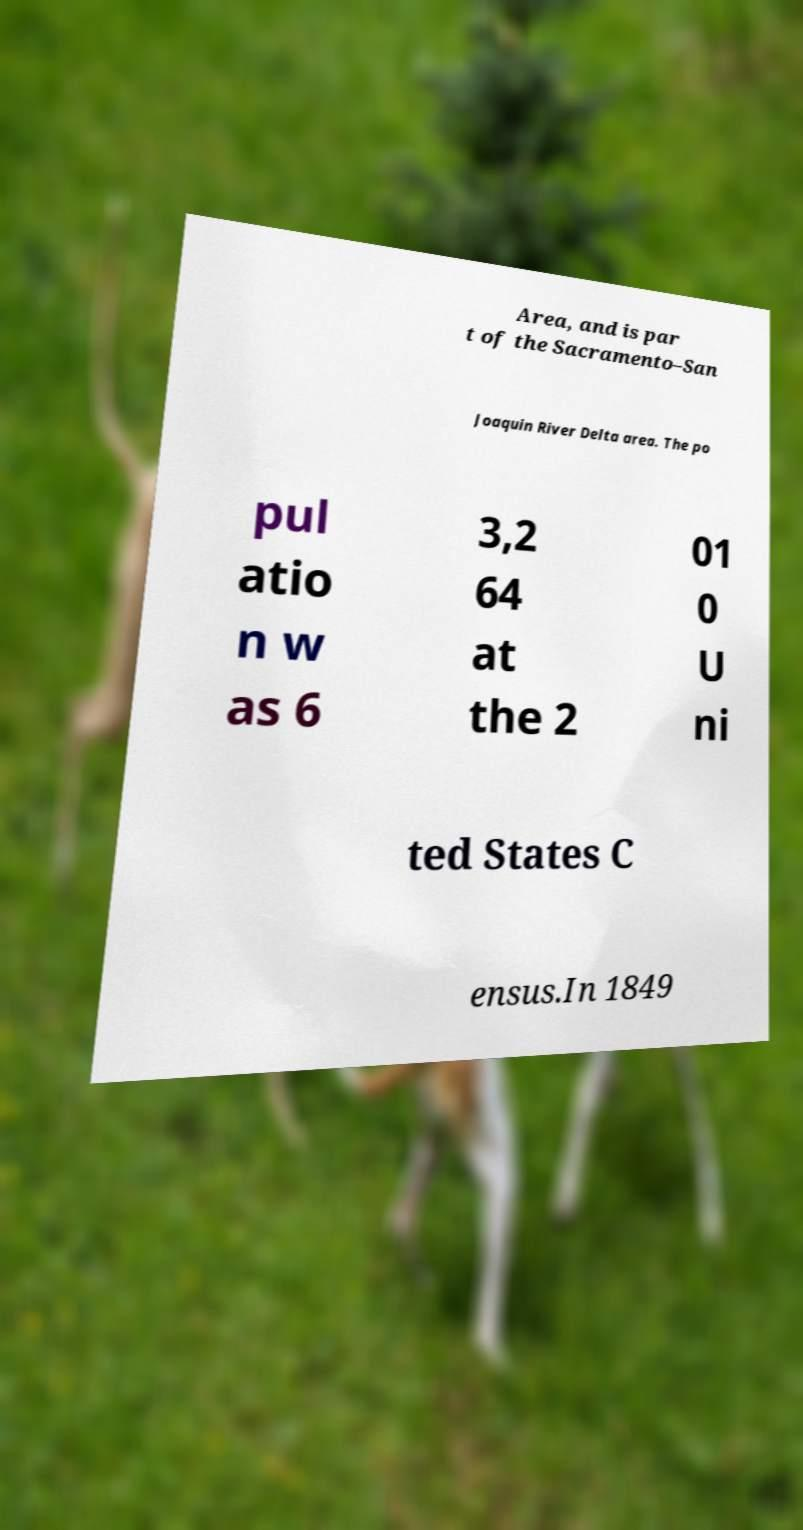There's text embedded in this image that I need extracted. Can you transcribe it verbatim? Area, and is par t of the Sacramento–San Joaquin River Delta area. The po pul atio n w as 6 3,2 64 at the 2 01 0 U ni ted States C ensus.In 1849 